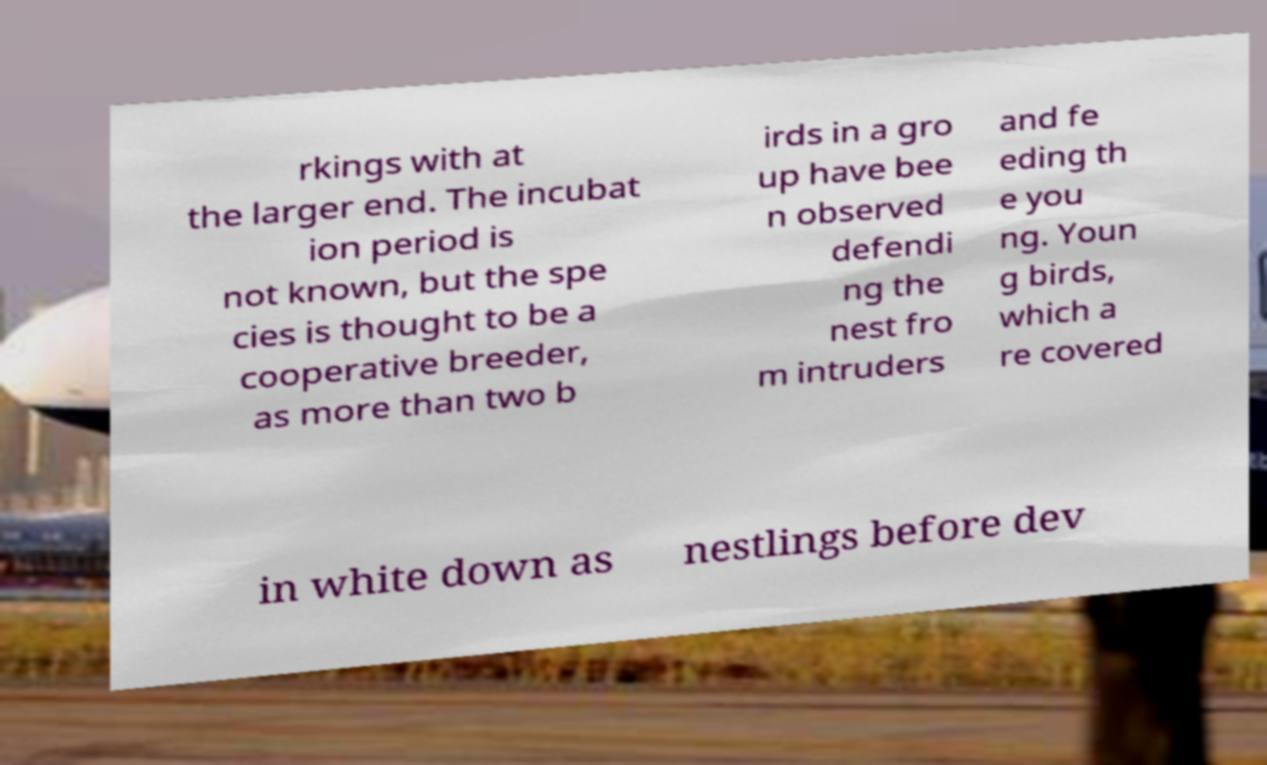Can you accurately transcribe the text from the provided image for me? rkings with at the larger end. The incubat ion period is not known, but the spe cies is thought to be a cooperative breeder, as more than two b irds in a gro up have bee n observed defendi ng the nest fro m intruders and fe eding th e you ng. Youn g birds, which a re covered in white down as nestlings before dev 